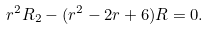Convert formula to latex. <formula><loc_0><loc_0><loc_500><loc_500>r ^ { 2 } R _ { 2 } - ( r ^ { 2 } - 2 r + 6 ) R = 0 .</formula> 